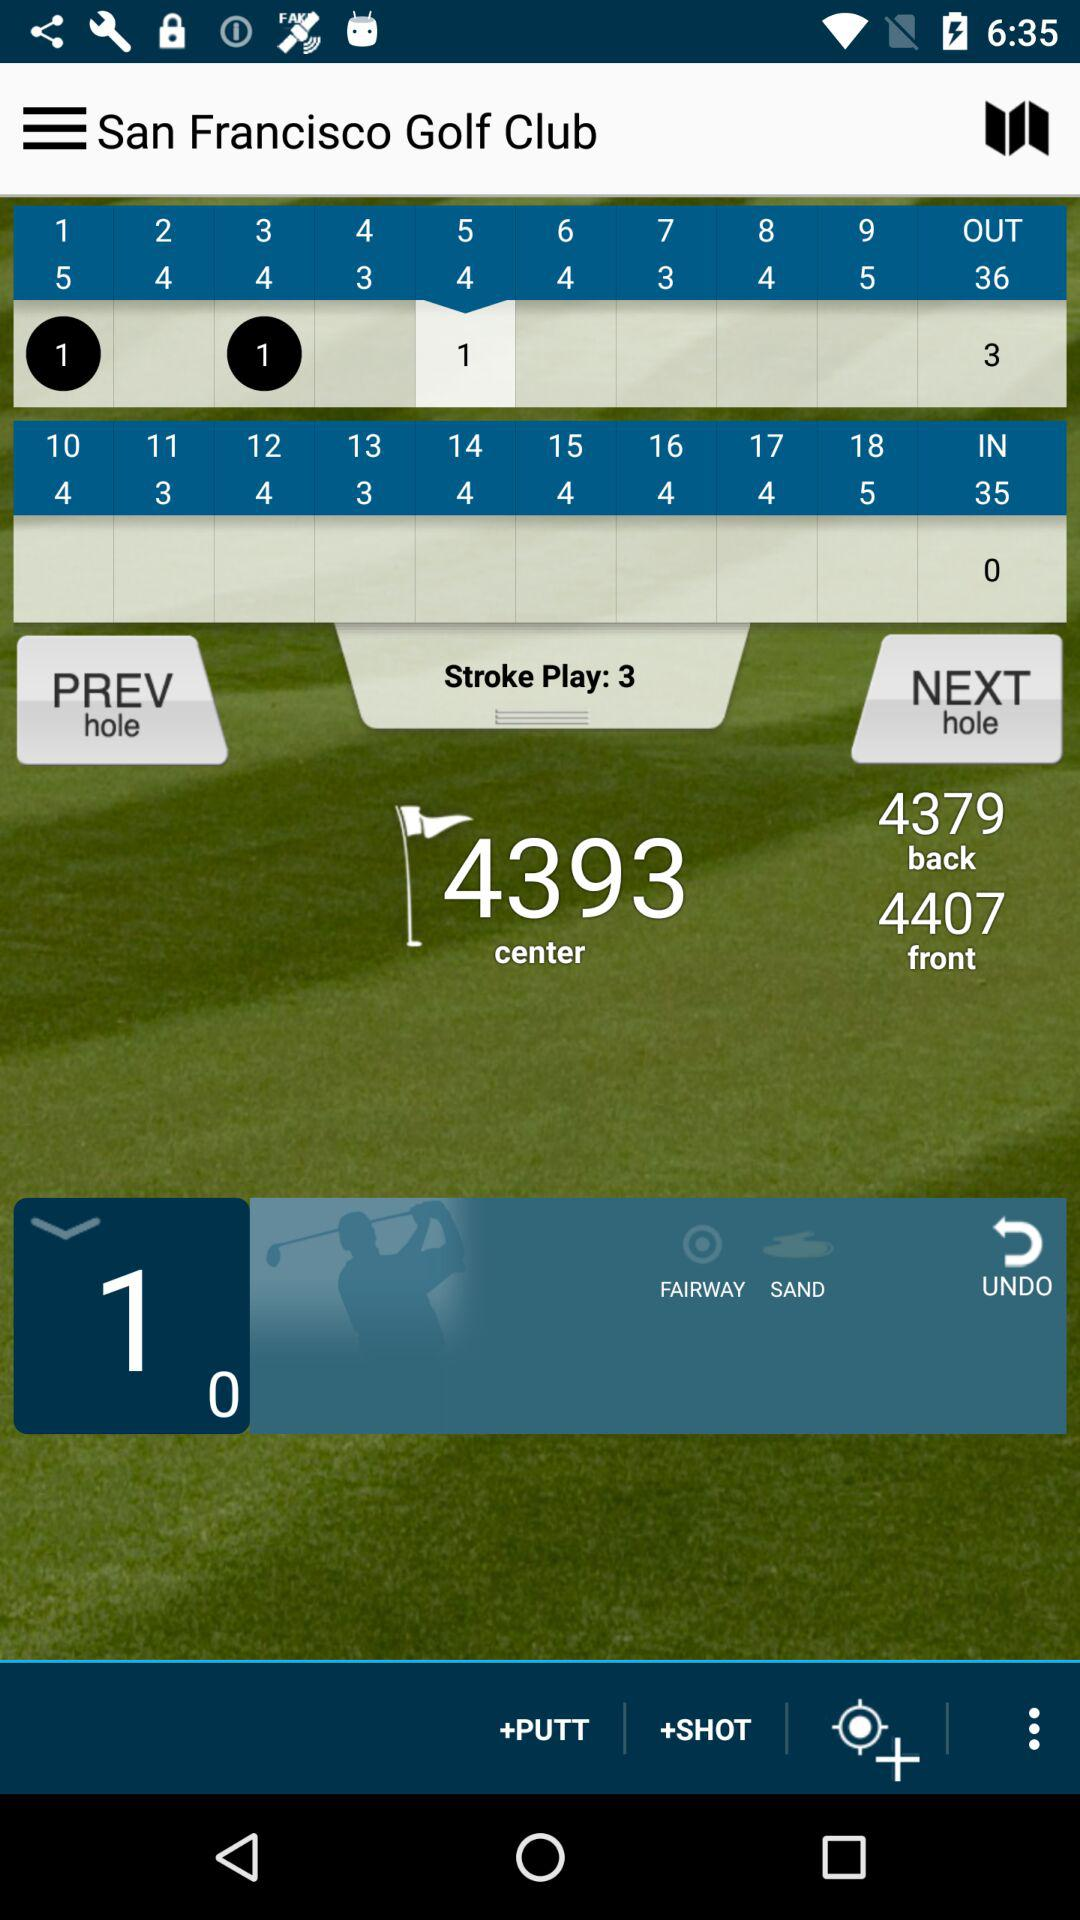What is the back score? The back score is 4379. 